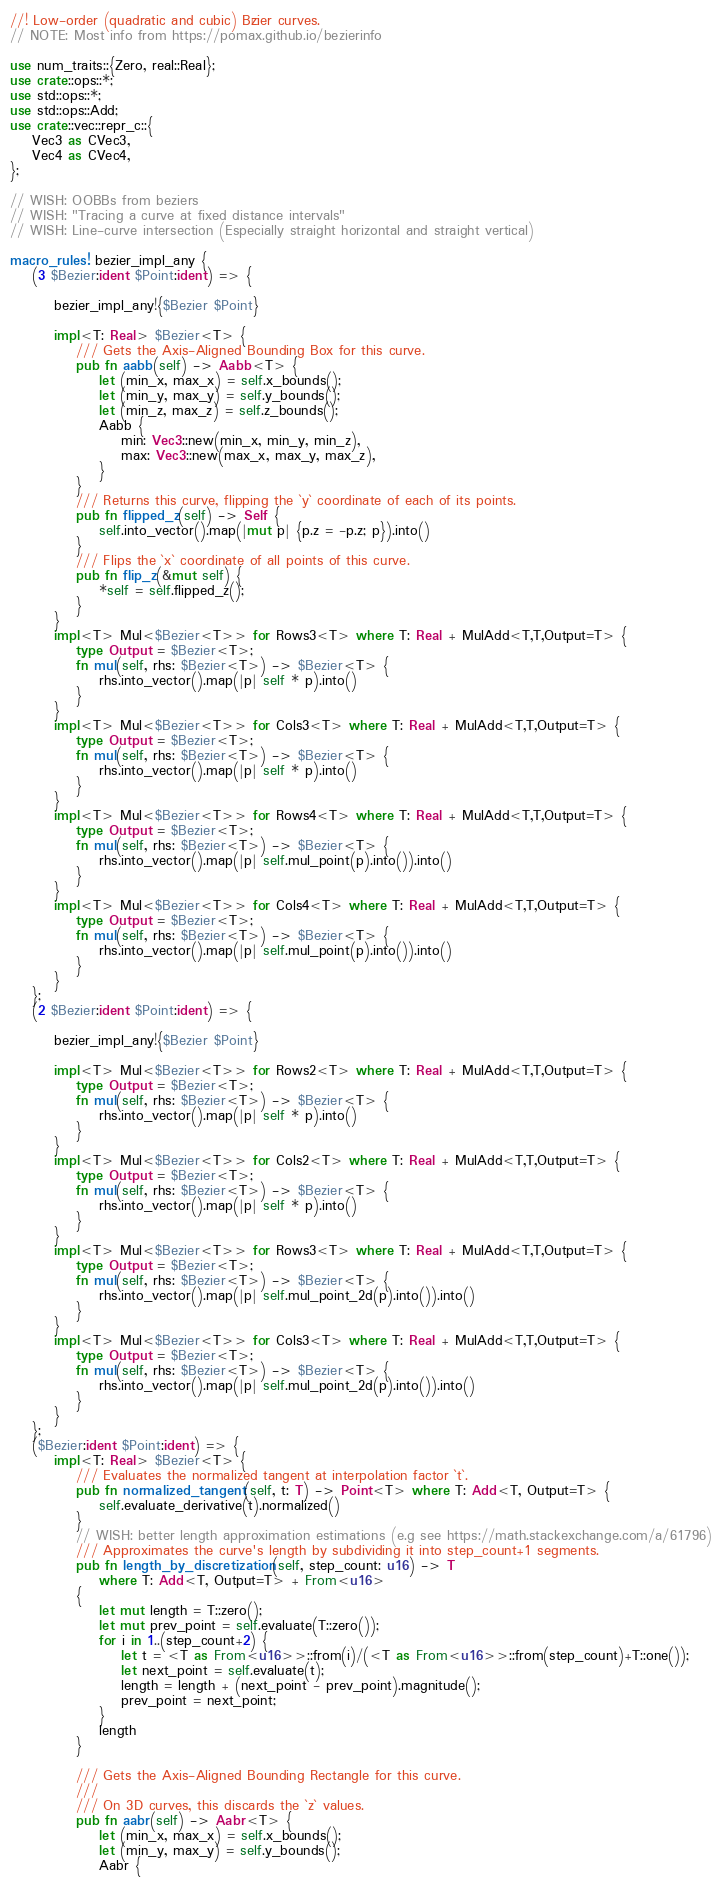Convert code to text. <code><loc_0><loc_0><loc_500><loc_500><_Rust_>//! Low-order (quadratic and cubic) Bézier curves.
// NOTE: Most info from https://pomax.github.io/bezierinfo

use num_traits::{Zero, real::Real};
use crate::ops::*;
use std::ops::*;
use std::ops::Add;
use crate::vec::repr_c::{
    Vec3 as CVec3,
    Vec4 as CVec4,
};

// WISH: OOBBs from beziers
// WISH: "Tracing a curve at fixed distance intervals"
// WISH: Line-curve intersection (Especially straight horizontal and straight vertical)

macro_rules! bezier_impl_any {
    (3 $Bezier:ident $Point:ident) => {

        bezier_impl_any!{$Bezier $Point}

        impl<T: Real> $Bezier<T> {
            /// Gets the Axis-Aligned Bounding Box for this curve.
            pub fn aabb(self) -> Aabb<T> {
                let (min_x, max_x) = self.x_bounds();
                let (min_y, max_y) = self.y_bounds();
                let (min_z, max_z) = self.z_bounds();
                Aabb {
                    min: Vec3::new(min_x, min_y, min_z),
                    max: Vec3::new(max_x, max_y, max_z),
                }
            }
            /// Returns this curve, flipping the `y` coordinate of each of its points.
            pub fn flipped_z(self) -> Self {
                self.into_vector().map(|mut p| {p.z = -p.z; p}).into()
            }
            /// Flips the `x` coordinate of all points of this curve.
            pub fn flip_z(&mut self) {
                *self = self.flipped_z();
            }
        }
        impl<T> Mul<$Bezier<T>> for Rows3<T> where T: Real + MulAdd<T,T,Output=T> {
            type Output = $Bezier<T>;
            fn mul(self, rhs: $Bezier<T>) -> $Bezier<T> {
                rhs.into_vector().map(|p| self * p).into()
            }
        }
        impl<T> Mul<$Bezier<T>> for Cols3<T> where T: Real + MulAdd<T,T,Output=T> {
            type Output = $Bezier<T>;
            fn mul(self, rhs: $Bezier<T>) -> $Bezier<T> {
                rhs.into_vector().map(|p| self * p).into()
            }
        }
        impl<T> Mul<$Bezier<T>> for Rows4<T> where T: Real + MulAdd<T,T,Output=T> {
            type Output = $Bezier<T>;
            fn mul(self, rhs: $Bezier<T>) -> $Bezier<T> {
                rhs.into_vector().map(|p| self.mul_point(p).into()).into()
            }
        }
        impl<T> Mul<$Bezier<T>> for Cols4<T> where T: Real + MulAdd<T,T,Output=T> {
            type Output = $Bezier<T>;
            fn mul(self, rhs: $Bezier<T>) -> $Bezier<T> {
                rhs.into_vector().map(|p| self.mul_point(p).into()).into()
            }
        }
    };
    (2 $Bezier:ident $Point:ident) => {

        bezier_impl_any!{$Bezier $Point}

        impl<T> Mul<$Bezier<T>> for Rows2<T> where T: Real + MulAdd<T,T,Output=T> {
            type Output = $Bezier<T>;
            fn mul(self, rhs: $Bezier<T>) -> $Bezier<T> {
                rhs.into_vector().map(|p| self * p).into()
            }
        }
        impl<T> Mul<$Bezier<T>> for Cols2<T> where T: Real + MulAdd<T,T,Output=T> {
            type Output = $Bezier<T>;
            fn mul(self, rhs: $Bezier<T>) -> $Bezier<T> {
                rhs.into_vector().map(|p| self * p).into()
            }
        }
        impl<T> Mul<$Bezier<T>> for Rows3<T> where T: Real + MulAdd<T,T,Output=T> {
            type Output = $Bezier<T>;
            fn mul(self, rhs: $Bezier<T>) -> $Bezier<T> {
                rhs.into_vector().map(|p| self.mul_point_2d(p).into()).into()
            }
        }
        impl<T> Mul<$Bezier<T>> for Cols3<T> where T: Real + MulAdd<T,T,Output=T> {
            type Output = $Bezier<T>;
            fn mul(self, rhs: $Bezier<T>) -> $Bezier<T> {
                rhs.into_vector().map(|p| self.mul_point_2d(p).into()).into()
            }
        }
    };
    ($Bezier:ident $Point:ident) => {
        impl<T: Real> $Bezier<T> {
            /// Evaluates the normalized tangent at interpolation factor `t`.
            pub fn normalized_tangent(self, t: T) -> Point<T> where T: Add<T, Output=T> {
                self.evaluate_derivative(t).normalized()
            }
            // WISH: better length approximation estimations (e.g see https://math.stackexchange.com/a/61796)
            /// Approximates the curve's length by subdividing it into step_count+1 segments.
            pub fn length_by_discretization(self, step_count: u16) -> T
                where T: Add<T, Output=T> + From<u16>
            {
                let mut length = T::zero();
                let mut prev_point = self.evaluate(T::zero());
                for i in 1..(step_count+2) {
                    let t = <T as From<u16>>::from(i)/(<T as From<u16>>::from(step_count)+T::one());
                    let next_point = self.evaluate(t);
                    length = length + (next_point - prev_point).magnitude();
                    prev_point = next_point;
                }
                length
            }

            /// Gets the Axis-Aligned Bounding Rectangle for this curve.
            ///
            /// On 3D curves, this discards the `z` values.
            pub fn aabr(self) -> Aabr<T> {
                let (min_x, max_x) = self.x_bounds();
                let (min_y, max_y) = self.y_bounds();
                Aabr {</code> 